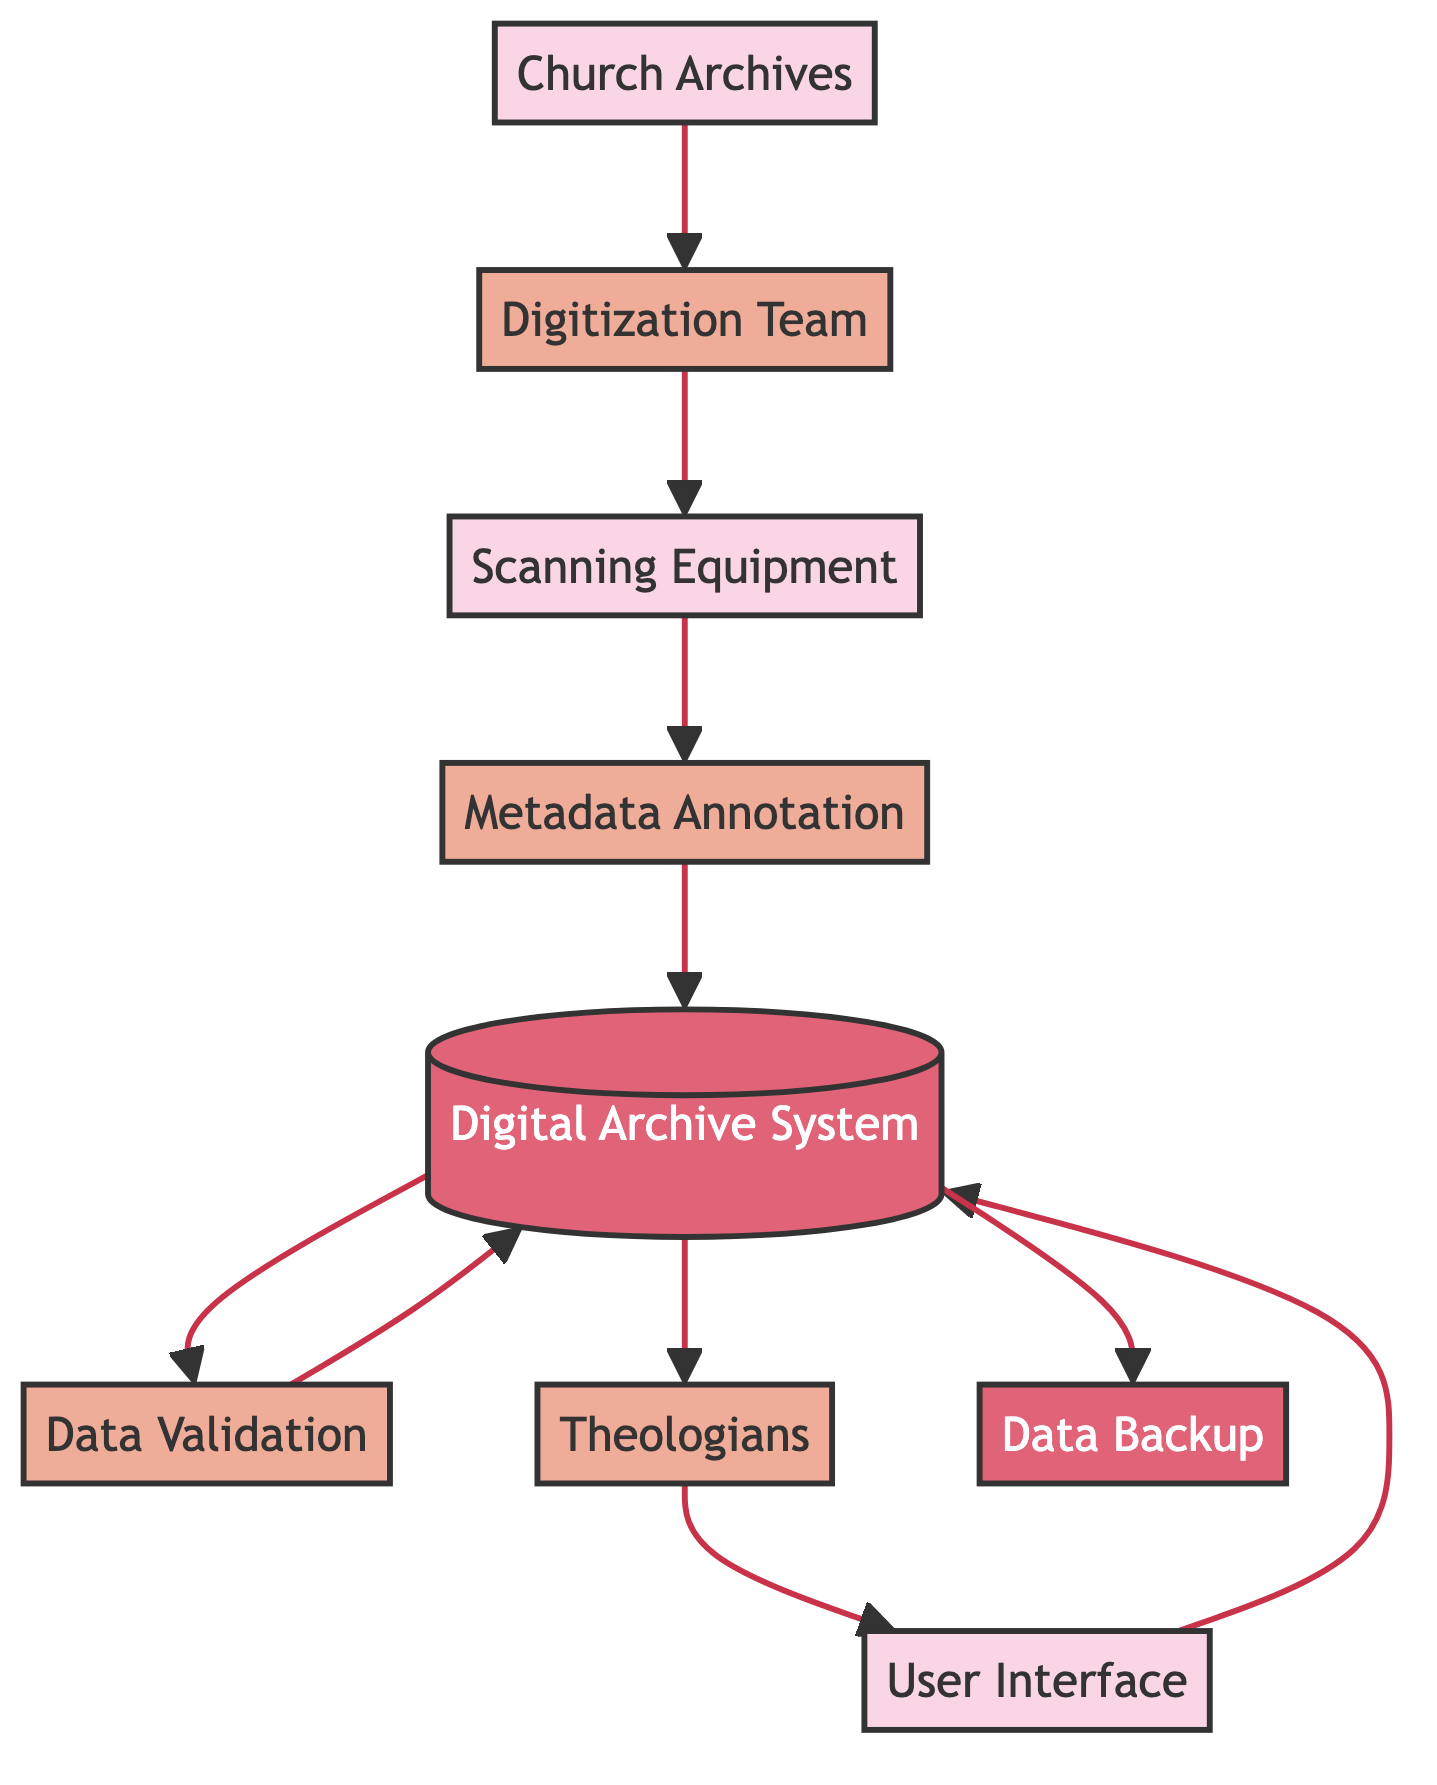What is the first step in the digitization workflow? The first step in the digitization workflow is the transfer of historical records from the Church Archives to the Digitization Team. This is indicated by the arrow connecting the Church Archives to the Digitization Team in the diagram.
Answer: Digitization Team How many distinct entities are represented in the diagram? To determine the number of distinct entities, we count the nodes labeled as entities in the diagram. There are four entities: Church Archives, Scanning Equipment, User Interface, and Digital Archive System.
Answer: Four What is the role of the Metadata Annotation process? The Metadata Annotation process involves adding metadata to the digital records. This ensures better searchability of the digital records, as indicated by the description for the Metadata Annotation entity connected to the Digital Archive System.
Answer: Adding metadata Who directly accesses the Digital Archive System? The Theologians are the ones who directly access the Digital Archive System as shown by the arrow leading from the Theologians to the User Interface, which in turn connects back to the Digital Archive System.
Answer: Theologians What is the relationship between Data Validation and the Digital Archive System? The relationship is that Data Validation is a process that occurs after digitized records are stored in the Digital Archive System. An arrow connects the Digital Archive System to Data Validation, indicating an interaction where validation checks may occur before records are finalized or further accessed.
Answer: Verification process What is the role of the Data Backup in the workflow? Data Backup is a process that ensures copies are created of all digitized records to prevent data loss. This is indicated by its connection to the Digital Archive System, which shows that backup occurs after records are maintained in the system.
Answer: Prevent data loss Which team is responsible for scanning the historical records? The Digitization Team is responsible for scanning the historical records as the diagram shows an arrow from Church Archives to Digitization Team indicating that they handle the digitization process.
Answer: Digitization Team What equipment is used in the digitization process? Scanning Equipment is used for digitization, including devices like scanners and cameras. The diagram specifically lists Scanning Equipment as a part of the workflow immediately following the Digitization Team.
Answer: Scanning Equipment What follows after the Metadata Annotation step? After Metadata Annotation, the next step is the storage of the annotated records in the Digital Archive System. The sequence in the diagram shows the progression from Metadata Annotation to Digital Archive System.
Answer: Digital Archive System How is the User Interface connected in the diagram? The User Interface is connected in the diagram as a means through which Theologians access the Digital Archive System. The arrow indicates the flow from Theologians to the User Interface, which then interacts with the Digital Archive System.
Answer: Access point 